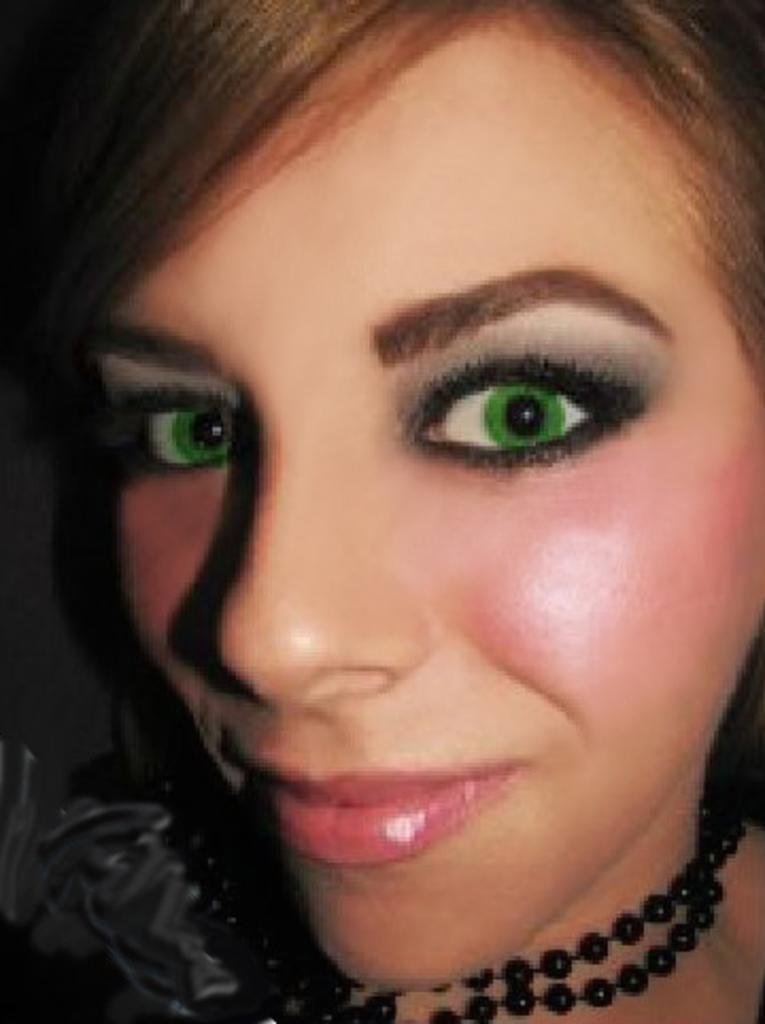In one or two sentences, can you explain what this image depicts? Here we can see woman face and wore chain. 